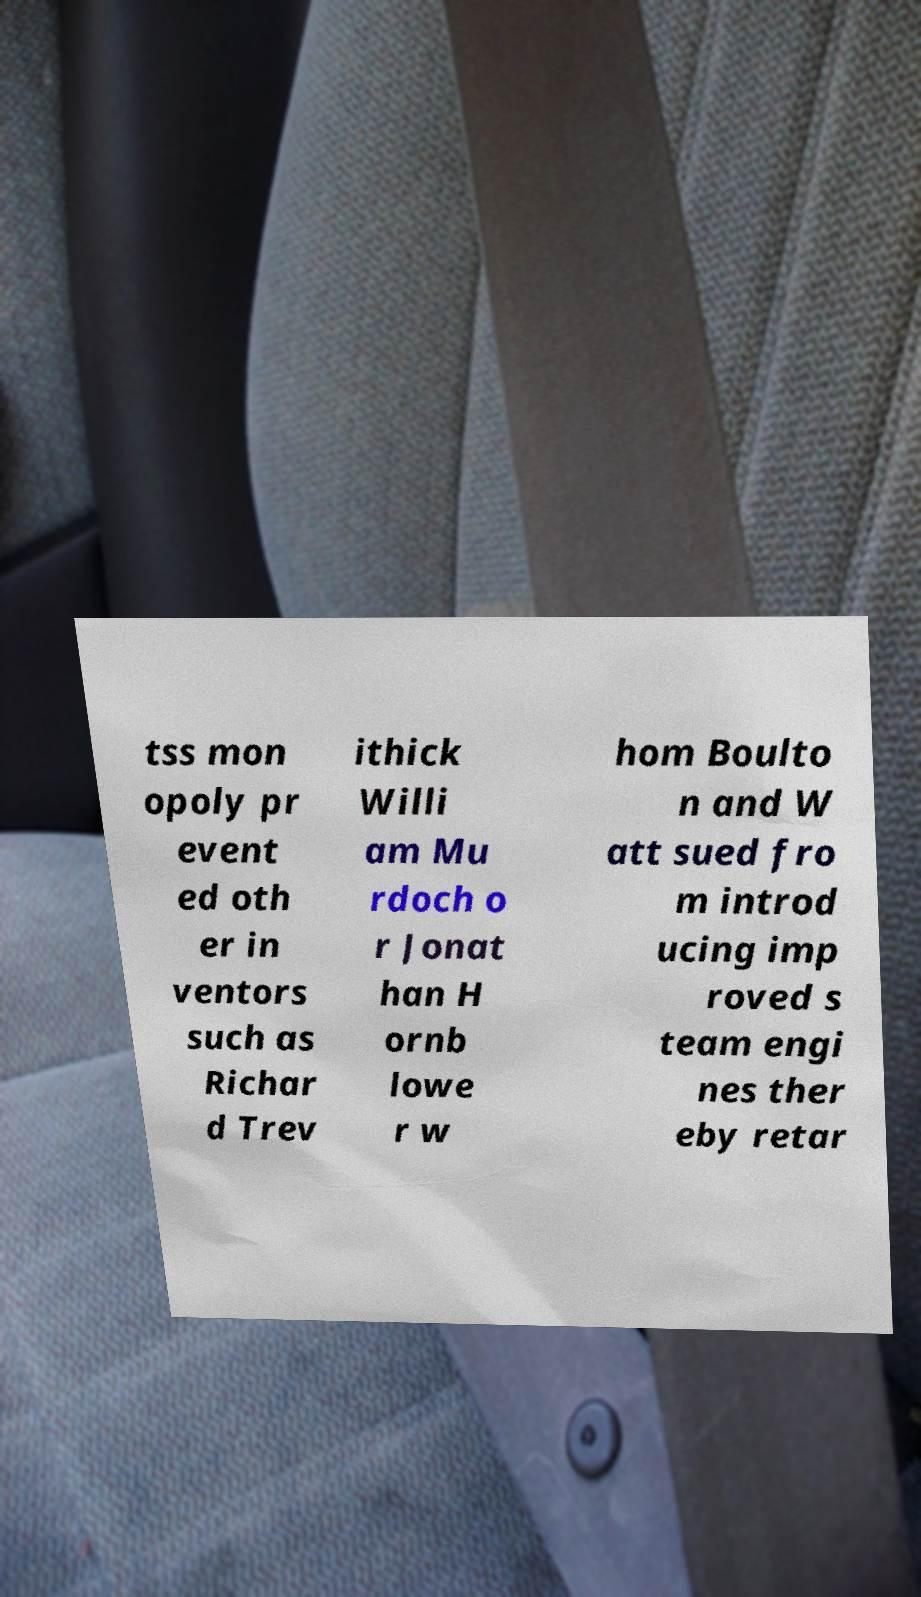Could you assist in decoding the text presented in this image and type it out clearly? tss mon opoly pr event ed oth er in ventors such as Richar d Trev ithick Willi am Mu rdoch o r Jonat han H ornb lowe r w hom Boulto n and W att sued fro m introd ucing imp roved s team engi nes ther eby retar 